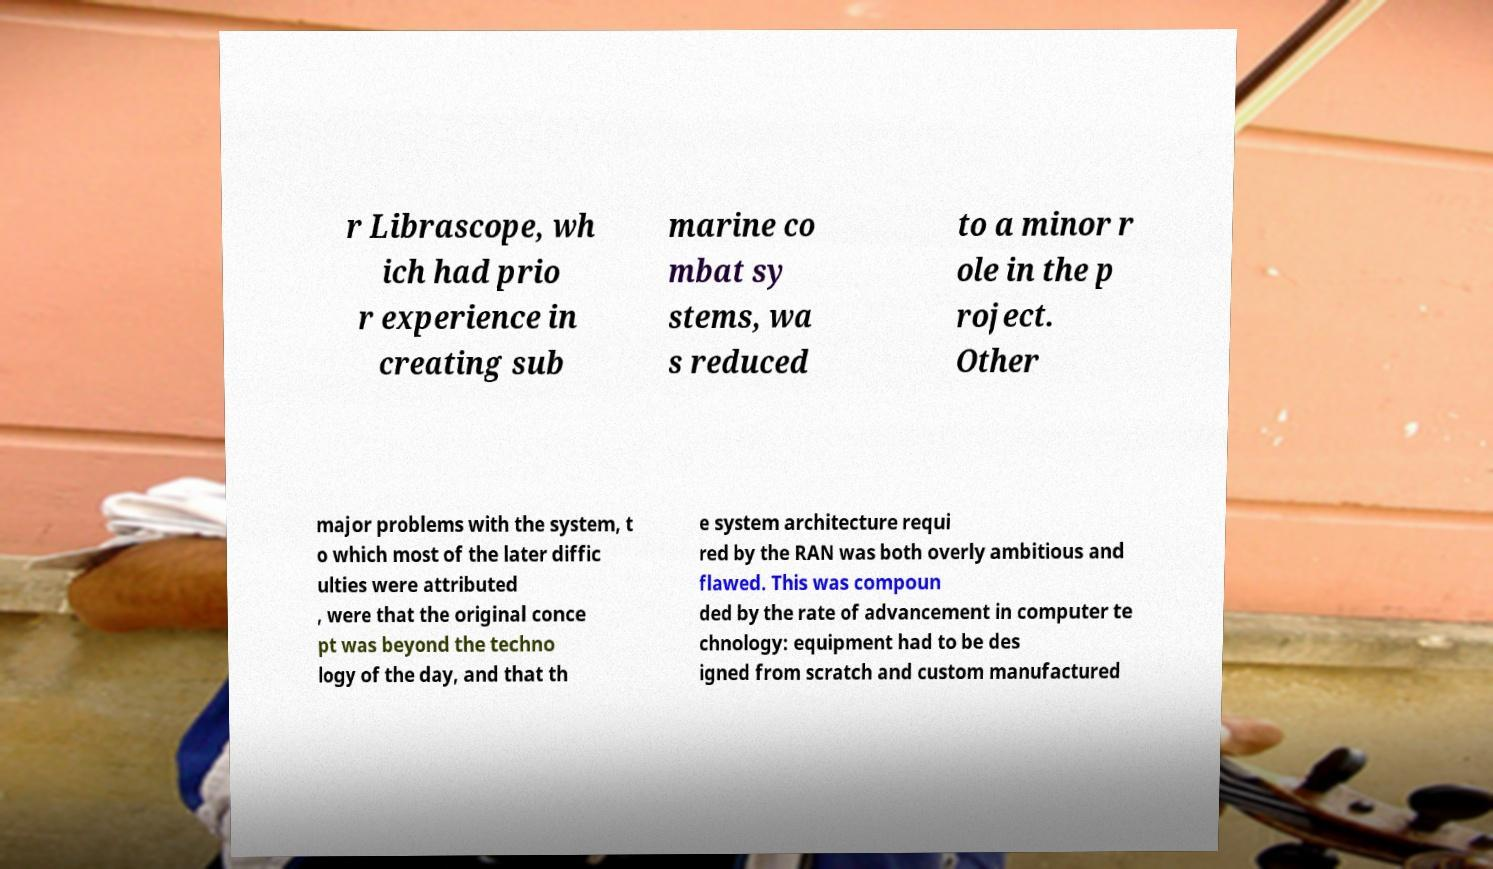What messages or text are displayed in this image? I need them in a readable, typed format. r Librascope, wh ich had prio r experience in creating sub marine co mbat sy stems, wa s reduced to a minor r ole in the p roject. Other major problems with the system, t o which most of the later diffic ulties were attributed , were that the original conce pt was beyond the techno logy of the day, and that th e system architecture requi red by the RAN was both overly ambitious and flawed. This was compoun ded by the rate of advancement in computer te chnology: equipment had to be des igned from scratch and custom manufactured 